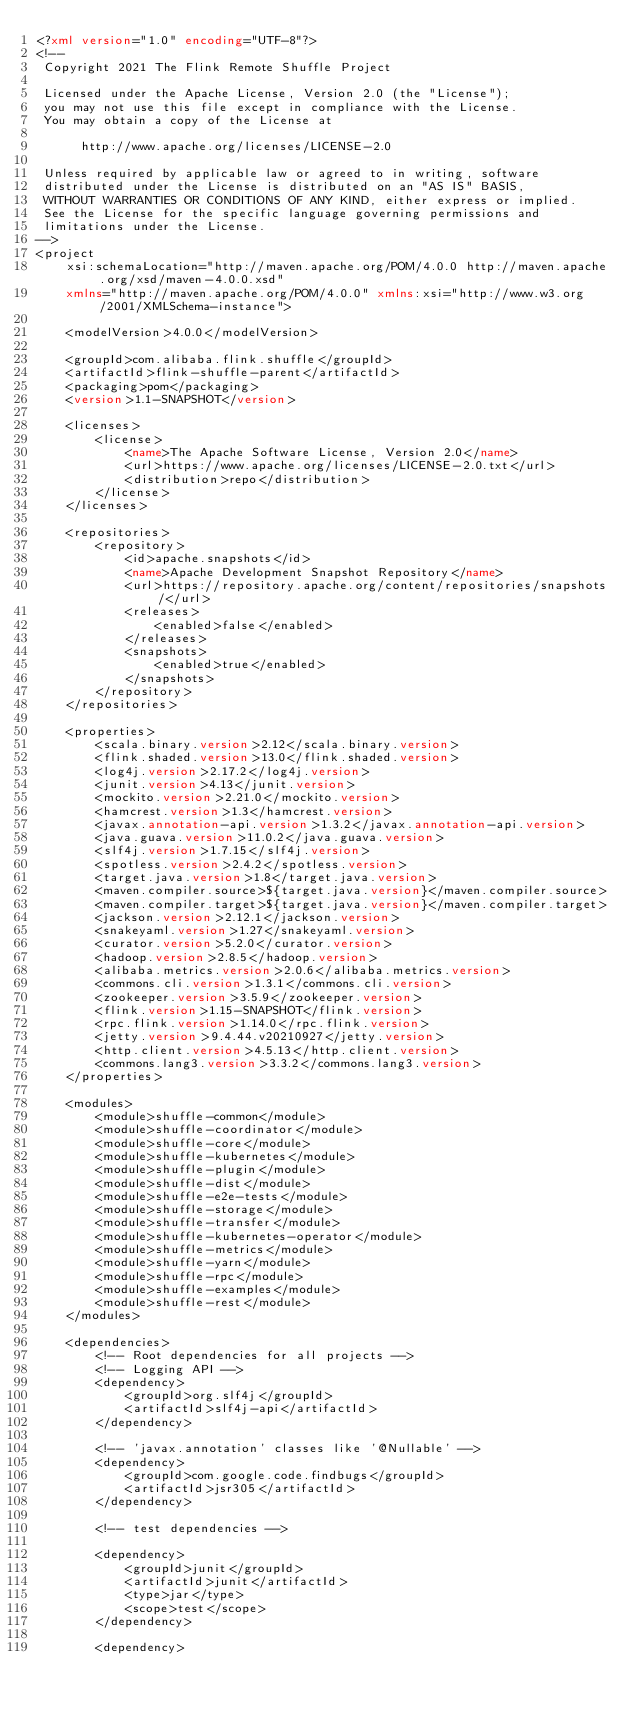Convert code to text. <code><loc_0><loc_0><loc_500><loc_500><_XML_><?xml version="1.0" encoding="UTF-8"?>
<!--
 Copyright 2021 The Flink Remote Shuffle Project

 Licensed under the Apache License, Version 2.0 (the "License");
 you may not use this file except in compliance with the License.
 You may obtain a copy of the License at

      http://www.apache.org/licenses/LICENSE-2.0

 Unless required by applicable law or agreed to in writing, software
 distributed under the License is distributed on an "AS IS" BASIS,
 WITHOUT WARRANTIES OR CONDITIONS OF ANY KIND, either express or implied.
 See the License for the specific language governing permissions and
 limitations under the License.
-->
<project
	xsi:schemaLocation="http://maven.apache.org/POM/4.0.0 http://maven.apache.org/xsd/maven-4.0.0.xsd"
	xmlns="http://maven.apache.org/POM/4.0.0" xmlns:xsi="http://www.w3.org/2001/XMLSchema-instance">

	<modelVersion>4.0.0</modelVersion>

	<groupId>com.alibaba.flink.shuffle</groupId>
	<artifactId>flink-shuffle-parent</artifactId>
	<packaging>pom</packaging>
	<version>1.1-SNAPSHOT</version>

	<licenses>
		<license>
			<name>The Apache Software License, Version 2.0</name>
			<url>https://www.apache.org/licenses/LICENSE-2.0.txt</url>
			<distribution>repo</distribution>
		</license>
	</licenses>

	<repositories>
		<repository>
			<id>apache.snapshots</id>
			<name>Apache Development Snapshot Repository</name>
			<url>https://repository.apache.org/content/repositories/snapshots/</url>
			<releases>
				<enabled>false</enabled>
			</releases>
			<snapshots>
				<enabled>true</enabled>
			</snapshots>
		</repository>
	</repositories>

	<properties>
		<scala.binary.version>2.12</scala.binary.version>
		<flink.shaded.version>13.0</flink.shaded.version>
		<log4j.version>2.17.2</log4j.version>
		<junit.version>4.13</junit.version>
		<mockito.version>2.21.0</mockito.version>
		<hamcrest.version>1.3</hamcrest.version>
		<javax.annotation-api.version>1.3.2</javax.annotation-api.version>
		<java.guava.version>11.0.2</java.guava.version>
		<slf4j.version>1.7.15</slf4j.version>
		<spotless.version>2.4.2</spotless.version>
		<target.java.version>1.8</target.java.version>
		<maven.compiler.source>${target.java.version}</maven.compiler.source>
		<maven.compiler.target>${target.java.version}</maven.compiler.target>
		<jackson.version>2.12.1</jackson.version>
		<snakeyaml.version>1.27</snakeyaml.version>
		<curator.version>5.2.0</curator.version>
		<hadoop.version>2.8.5</hadoop.version>
		<alibaba.metrics.version>2.0.6</alibaba.metrics.version>
		<commons.cli.version>1.3.1</commons.cli.version>
		<zookeeper.version>3.5.9</zookeeper.version>
		<flink.version>1.15-SNAPSHOT</flink.version>
		<rpc.flink.version>1.14.0</rpc.flink.version>
		<jetty.version>9.4.44.v20210927</jetty.version>
		<http.client.version>4.5.13</http.client.version>
		<commons.lang3.version>3.3.2</commons.lang3.version>
	</properties>

	<modules>
		<module>shuffle-common</module>
		<module>shuffle-coordinator</module>
		<module>shuffle-core</module>
		<module>shuffle-kubernetes</module>
		<module>shuffle-plugin</module>
		<module>shuffle-dist</module>
		<module>shuffle-e2e-tests</module>
		<module>shuffle-storage</module>
		<module>shuffle-transfer</module>
		<module>shuffle-kubernetes-operator</module>
		<module>shuffle-metrics</module>
		<module>shuffle-yarn</module>
		<module>shuffle-rpc</module>
		<module>shuffle-examples</module>
		<module>shuffle-rest</module>
	</modules>

	<dependencies>
		<!-- Root dependencies for all projects -->
		<!-- Logging API -->
		<dependency>
			<groupId>org.slf4j</groupId>
			<artifactId>slf4j-api</artifactId>
		</dependency>

		<!-- 'javax.annotation' classes like '@Nullable' -->
		<dependency>
			<groupId>com.google.code.findbugs</groupId>
			<artifactId>jsr305</artifactId>
		</dependency>

		<!-- test dependencies -->

		<dependency>
			<groupId>junit</groupId>
			<artifactId>junit</artifactId>
			<type>jar</type>
			<scope>test</scope>
		</dependency>

		<dependency></code> 